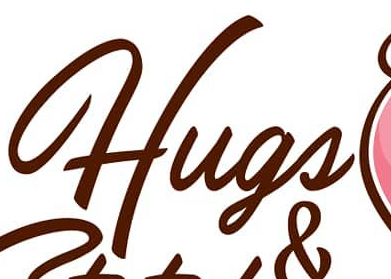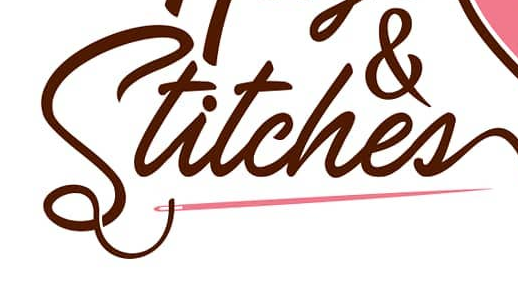What words can you see in these images in sequence, separated by a semicolon? Hugs; Stitches 